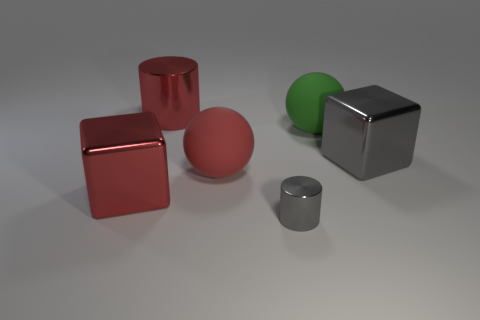Add 2 big blue metallic spheres. How many objects exist? 8 Subtract all cubes. How many objects are left? 4 Add 4 green rubber spheres. How many green rubber spheres exist? 5 Subtract 0 blue blocks. How many objects are left? 6 Subtract all big cylinders. Subtract all red cylinders. How many objects are left? 4 Add 3 cylinders. How many cylinders are left? 5 